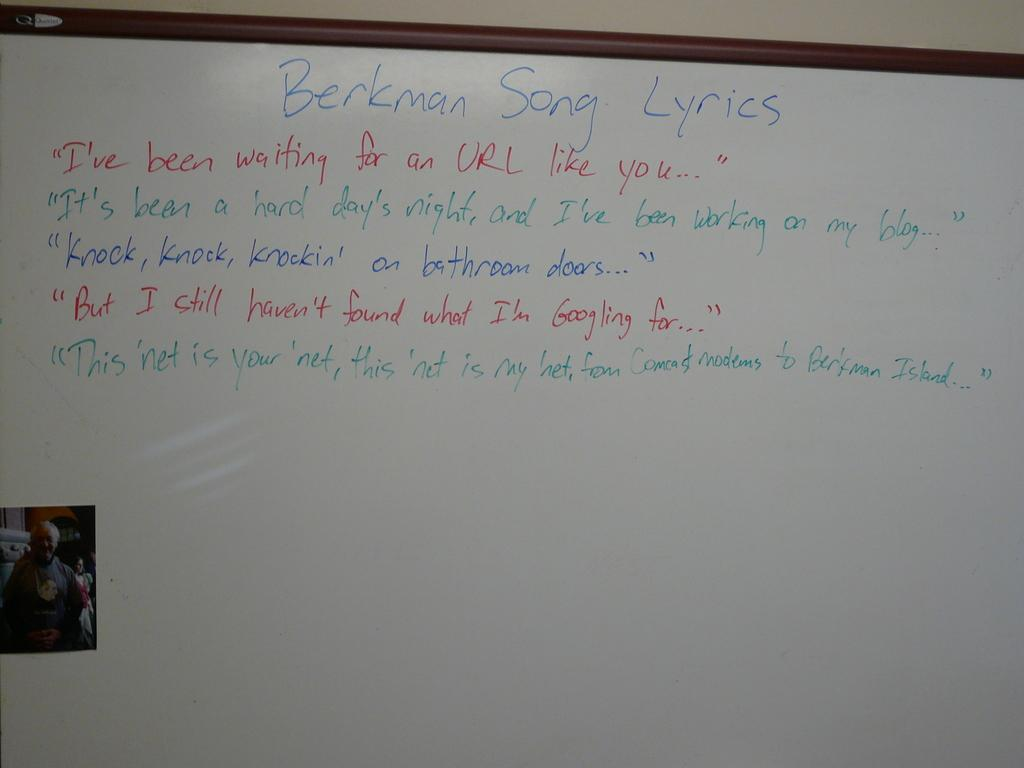Provide a one-sentence caption for the provided image. A whiteboard with Berkman Song lyrics in alternating lines of red, green and blue with a small photo of a man in the lower left corner. 